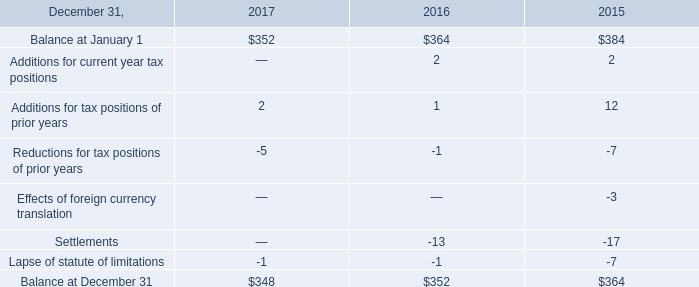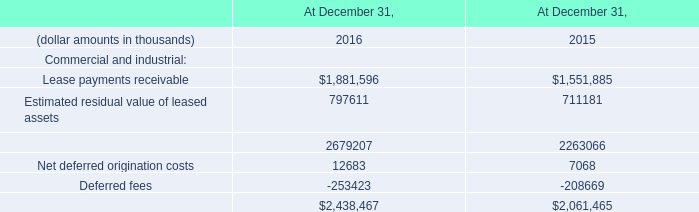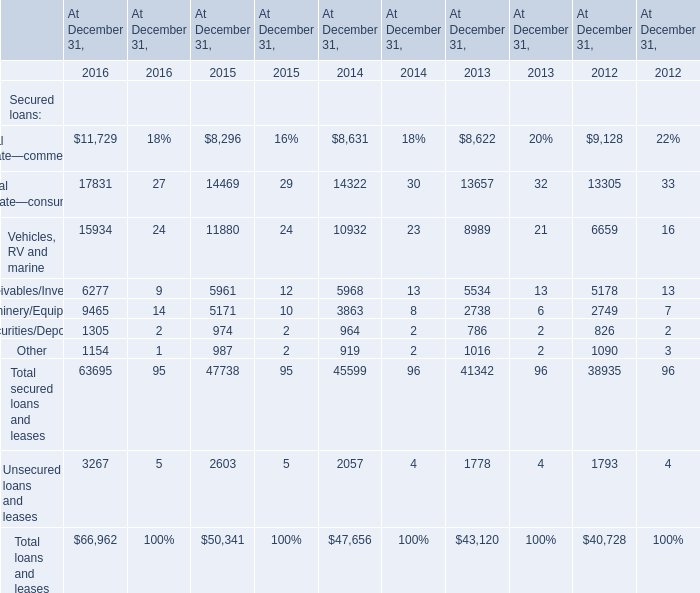What's the sum of Unsecured loans and leases of At December 31, 2014, and Net deferred origination costs of At December 31, 2015 ? 
Computations: (2057.0 + 7068.0)
Answer: 9125.0. 